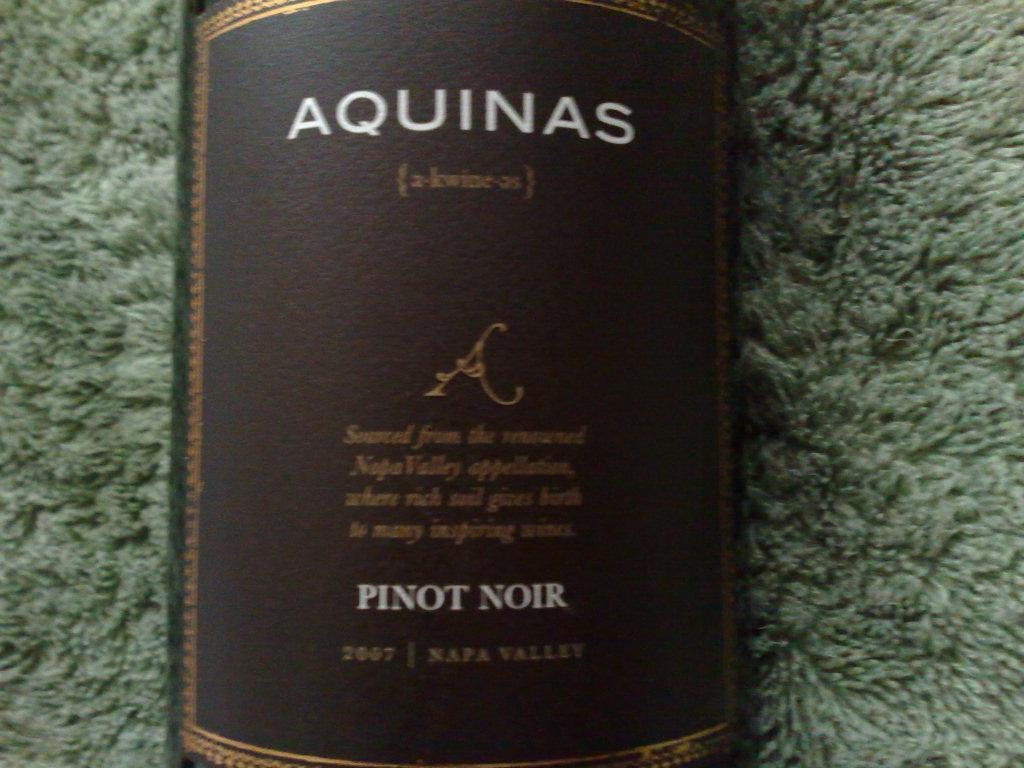<image>
Offer a succinct explanation of the picture presented. A bottle of Pinot Noir wine with a brown label and the word Aquinas written on it. 